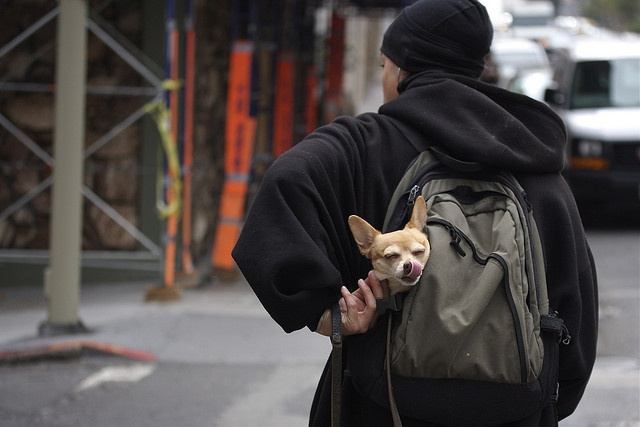Describe the objects in this image and their specific colors. I can see people in black, gray, and darkgray tones, backpack in black and gray tones, car in black, white, gray, and darkgray tones, dog in black, gray, and tan tones, and car in black, lightgray, darkgray, and gray tones in this image. 